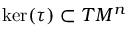<formula> <loc_0><loc_0><loc_500><loc_500>\ker ( \tau ) \subset T M ^ { n }</formula> 